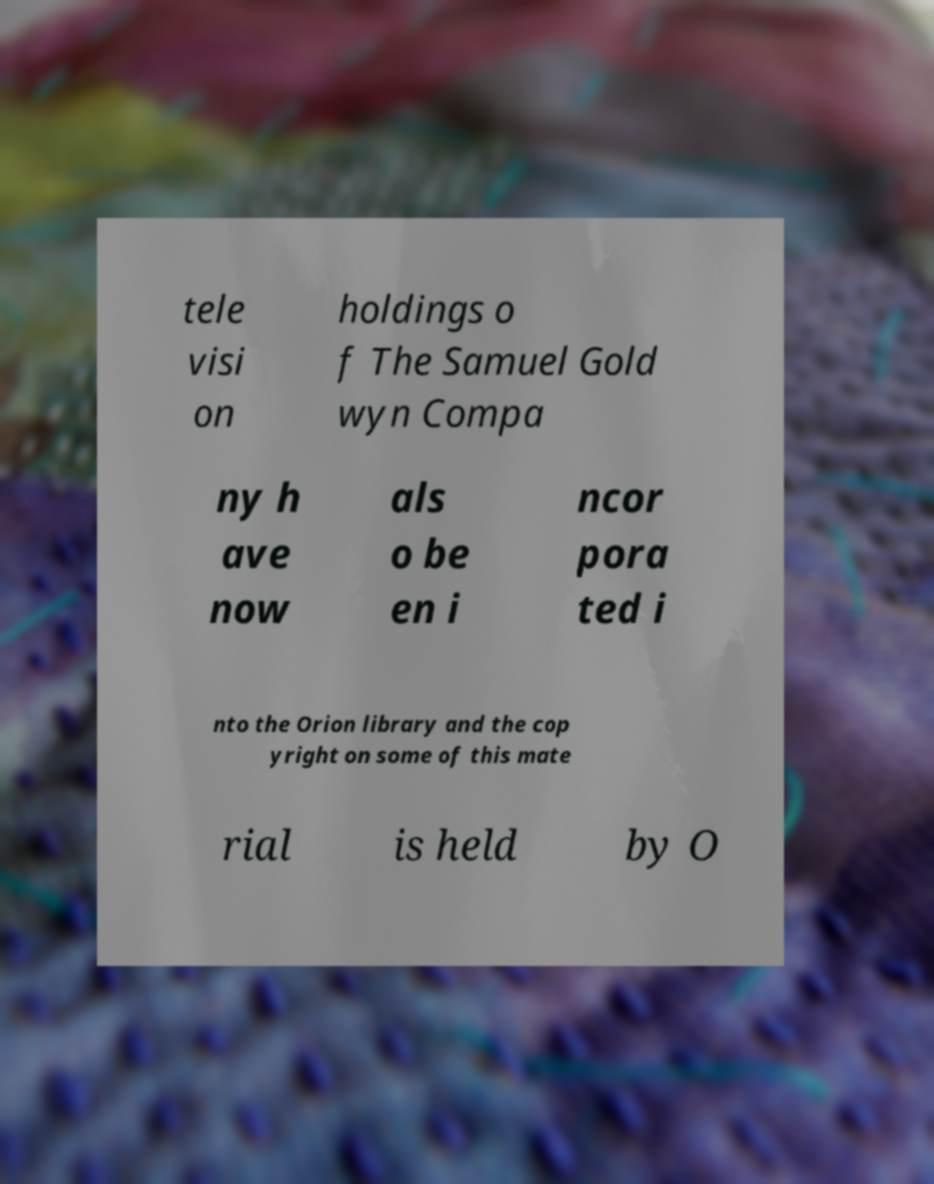For documentation purposes, I need the text within this image transcribed. Could you provide that? tele visi on holdings o f The Samuel Gold wyn Compa ny h ave now als o be en i ncor pora ted i nto the Orion library and the cop yright on some of this mate rial is held by O 